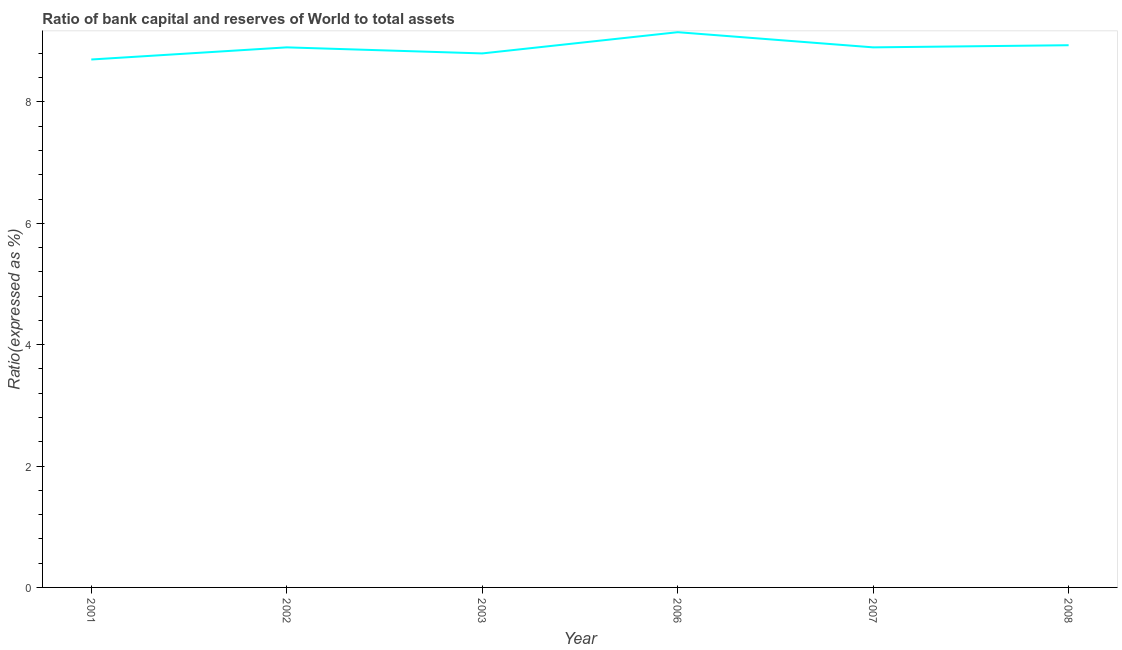What is the bank capital to assets ratio in 2002?
Your answer should be very brief. 8.9. Across all years, what is the maximum bank capital to assets ratio?
Provide a short and direct response. 9.15. In which year was the bank capital to assets ratio maximum?
Your answer should be very brief. 2006. What is the sum of the bank capital to assets ratio?
Offer a very short reply. 53.39. What is the difference between the bank capital to assets ratio in 2006 and 2007?
Make the answer very short. 0.25. What is the average bank capital to assets ratio per year?
Offer a terse response. 8.9. In how many years, is the bank capital to assets ratio greater than 2.4 %?
Your answer should be compact. 6. What is the ratio of the bank capital to assets ratio in 2002 to that in 2006?
Ensure brevity in your answer.  0.97. Is the bank capital to assets ratio in 2001 less than that in 2002?
Your answer should be compact. Yes. What is the difference between the highest and the second highest bank capital to assets ratio?
Ensure brevity in your answer.  0.21. What is the difference between the highest and the lowest bank capital to assets ratio?
Your response must be concise. 0.45. In how many years, is the bank capital to assets ratio greater than the average bank capital to assets ratio taken over all years?
Provide a short and direct response. 4. What is the difference between two consecutive major ticks on the Y-axis?
Ensure brevity in your answer.  2. What is the title of the graph?
Provide a succinct answer. Ratio of bank capital and reserves of World to total assets. What is the label or title of the Y-axis?
Keep it short and to the point. Ratio(expressed as %). What is the Ratio(expressed as %) of 2001?
Keep it short and to the point. 8.7. What is the Ratio(expressed as %) in 2006?
Your answer should be compact. 9.15. What is the Ratio(expressed as %) in 2007?
Your response must be concise. 8.9. What is the Ratio(expressed as %) in 2008?
Offer a very short reply. 8.94. What is the difference between the Ratio(expressed as %) in 2001 and 2006?
Provide a succinct answer. -0.45. What is the difference between the Ratio(expressed as %) in 2001 and 2008?
Your answer should be very brief. -0.24. What is the difference between the Ratio(expressed as %) in 2002 and 2008?
Your answer should be very brief. -0.04. What is the difference between the Ratio(expressed as %) in 2003 and 2006?
Provide a succinct answer. -0.35. What is the difference between the Ratio(expressed as %) in 2003 and 2007?
Keep it short and to the point. -0.1. What is the difference between the Ratio(expressed as %) in 2003 and 2008?
Give a very brief answer. -0.14. What is the difference between the Ratio(expressed as %) in 2006 and 2008?
Your answer should be very brief. 0.21. What is the difference between the Ratio(expressed as %) in 2007 and 2008?
Make the answer very short. -0.04. What is the ratio of the Ratio(expressed as %) in 2001 to that in 2002?
Give a very brief answer. 0.98. What is the ratio of the Ratio(expressed as %) in 2001 to that in 2006?
Make the answer very short. 0.95. What is the ratio of the Ratio(expressed as %) in 2001 to that in 2007?
Provide a short and direct response. 0.98. What is the ratio of the Ratio(expressed as %) in 2002 to that in 2007?
Provide a short and direct response. 1. What is the ratio of the Ratio(expressed as %) in 2002 to that in 2008?
Your answer should be very brief. 1. What is the ratio of the Ratio(expressed as %) in 2003 to that in 2006?
Your answer should be very brief. 0.96. What is the ratio of the Ratio(expressed as %) in 2006 to that in 2007?
Provide a succinct answer. 1.03. What is the ratio of the Ratio(expressed as %) in 2006 to that in 2008?
Offer a terse response. 1.02. 